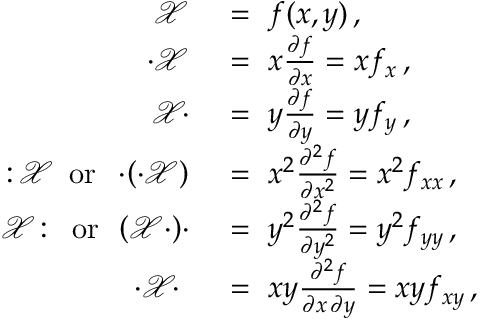<formula> <loc_0><loc_0><loc_500><loc_500>{ \begin{array} { r l } { { \mathcal { X } } \ } & { = \ f ( x , y ) \, , } \\ { \cdot { \mathcal { X } } \ } & { = \ x { \frac { \partial f } { \partial x } } = x f _ { x } \, , } \\ { { \mathcal { X } } \, \cdot \ } & { = \ y { \frac { \partial f } { \partial y } } = y f _ { y } \, , } \\ { \colon \, { \mathcal { X } } \, { o r } \, \cdot \, \left ( \cdot { \mathcal { X } } \right ) \ } & { = \ x ^ { 2 } { \frac { \partial ^ { 2 } f } { \partial x ^ { 2 } } } = x ^ { 2 } f _ { x x } \, , } \\ { { \mathcal { X } } \colon \, { o r } \, \left ( { \mathcal { X } } \cdot \right ) \, \cdot \ } & { = \ y ^ { 2 } { \frac { \partial ^ { 2 } f } { \partial y ^ { 2 } } } = y ^ { 2 } f _ { y y } \, , } \\ { \cdot { \mathcal { X } } \, \cdot \ \ } & { = \ x y { \frac { \partial ^ { 2 } f } { \partial x \, \partial y } } = x y f _ { x y } \, , } \end{array} }</formula> 